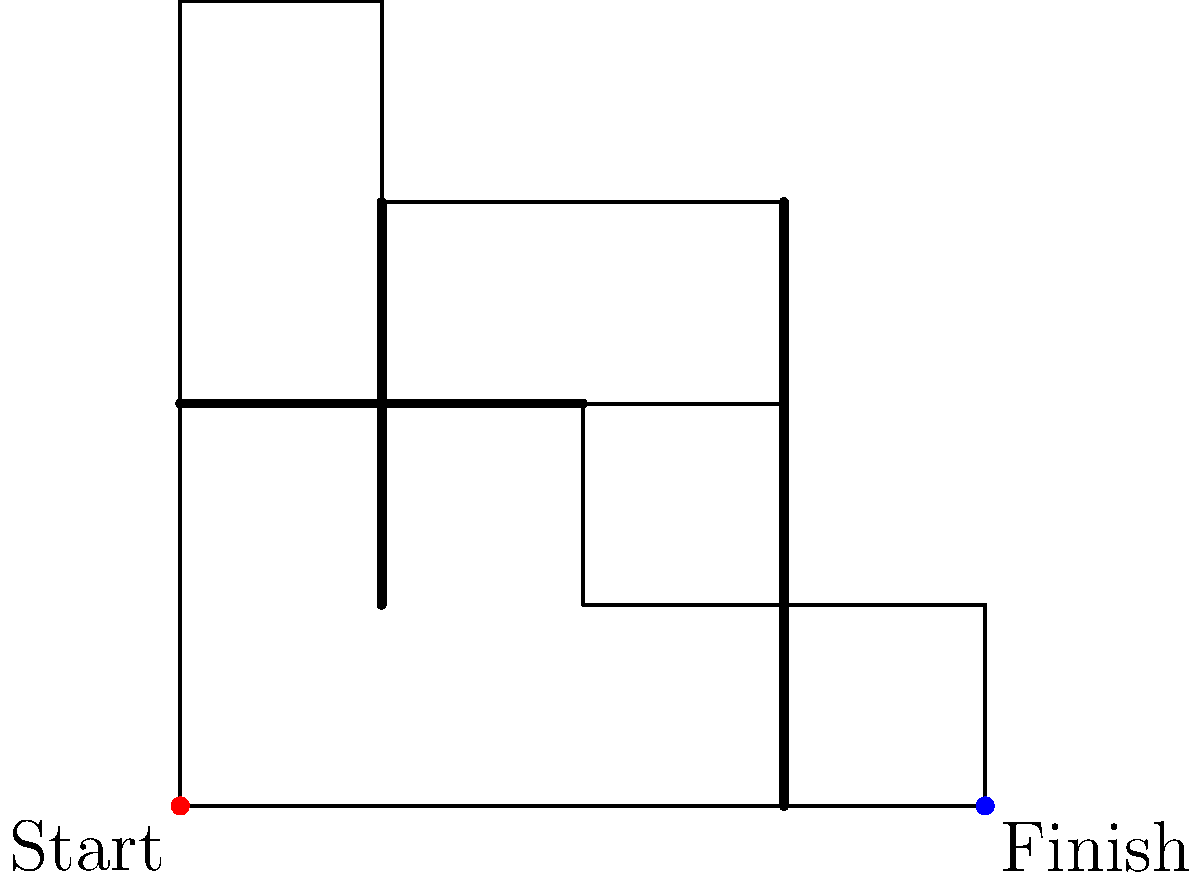As a team player with a strong work ethic, you're tasked with finding the most efficient route through a challenging field exercise. The diagram shows a maze-like field with obstacles. What is the minimum number of straight-line segments required to navigate from the start (red dot) to the finish (blue dot) without crossing any obstacles? Let's approach this step-by-step:

1. Analyze the maze:
   - The start point is at (0,0) and the finish point is at (4,0).
   - There are three main obstacles: a horizontal line from (0,2) to (2,2), a vertical line from (1,1) to (1,3), and another vertical line from (3,0) to (3,3).

2. Identify possible paths:
   - We can't go straight from start to finish due to the obstacle at (3,0) to (3,3).
   - We need to go around the obstacles, either above or below.

3. Find the shortest path:
   - The path with the fewest turns goes up, then right, then down.
   - This path consists of three straight-line segments:
     a. (0,0) to (0,4)
     b. (0,4) to (4,1)
     c. (4,1) to (4,0)

4. Verify the path:
   - This path doesn't cross any obstacles.
   - It uses the minimum number of turns possible to avoid all obstacles.

5. Count the segments:
   - The path consists of 3 straight-line segments.

Therefore, the minimum number of straight-line segments required is 3.
Answer: 3 